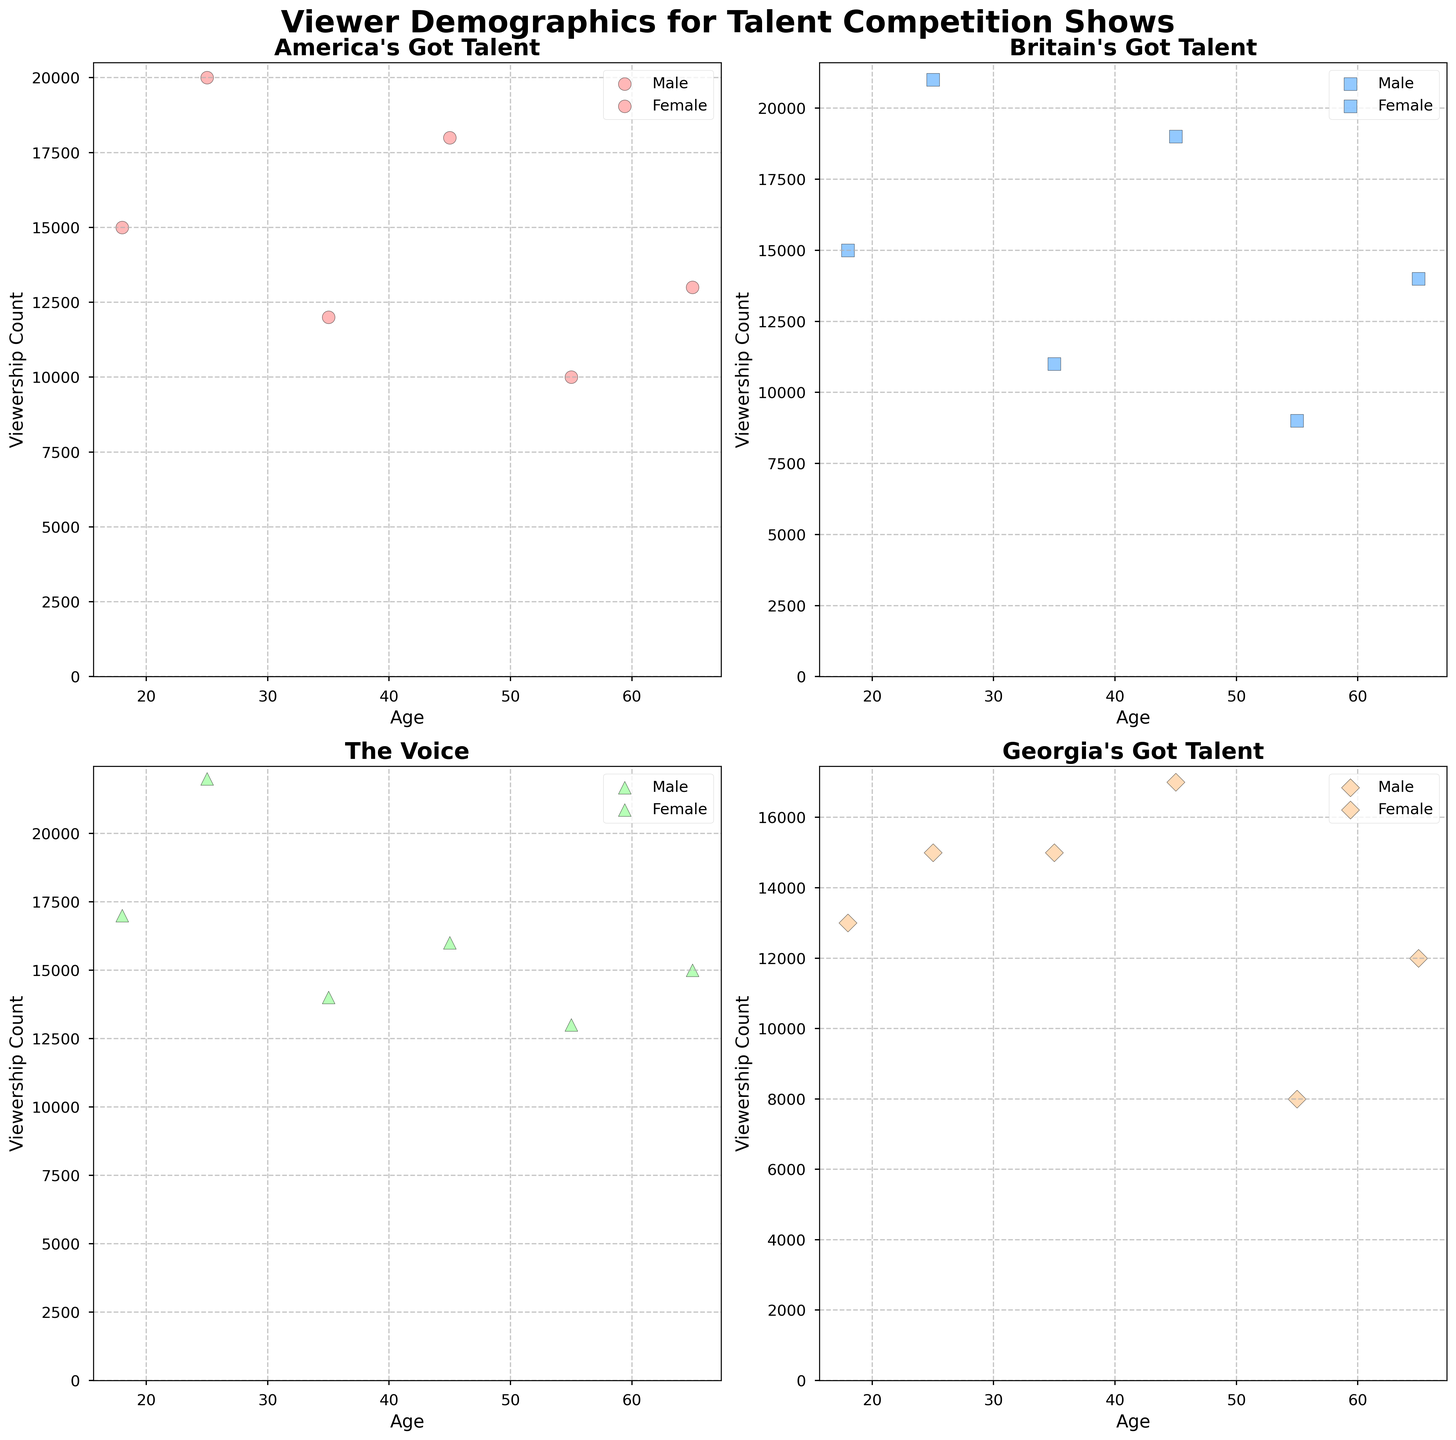What is the title of the figure? The title of the figure is displayed at the top of the plot, showing the main subject of the analysis.
Answer: Viewer Demographics for Talent Competition Shows Which show has the highest viewership count for the age group 25? By looking at the scatter plot for each show and comparing the viewership counts for the age group 25, we can identify the highest count.
Answer: The Voice For 'Britain's Got Talent', which gender has a higher viewership count at age 45? By examining the scatter plot for 'Britain's Got Talent', compare the viewership counts for male and female at age 45.
Answer: Male How many unique age groups are shown in the plots? By identifying the distinct age markers on the x-axes across all subplots, we can count the unique age groups.
Answer: 6 For 'Georgia's Got Talent', what is the average viewership count for females? For 'Georgia's Got Talent', add the viewership counts for females across all age groups and divide by the number of female data points. Calculation: (13000 + 15000 + 15000 + 8000) / 4 = 12750
Answer: 12750 Which age group has the most balanced viewership count between genders in 'America's Got Talent'? For 'America's Got Talent', look at the scatter plot and identify the age group where the viewership counts for both genders are closest in value.
Answer: Age 18 In 'The Voice', which age group shows the greatest difference in viewership count between males and females? By examining the scatter plot for 'The Voice', calculate the difference in viewership counts for each age group and identify the maximum difference. Calculation: Age 25 (22000 - 17000 = 5000), Age 35 (14000 - 14000 = 0), Age 45 (16000 - 16000 = 0), Age 18 (17000 - 13000 = 4000), Age 55 (13000 - 13000 = 0), Age 65 (15000 - 15000 = 0)
Answer: Age 25 Which show has the highest female viewership count overall? Compare the highest female viewership counts across all subplots for each show.
Answer: The Voice What is the total viewership count for males aged 55 across all four shows? Sum the viewership count for males aged 55 in each of the four subplots. Calculation: 10000 (AGT) + 14000 (BGT) + 13000 (The Voice) + 12000 (GGT) = 49000
Answer: 49000 